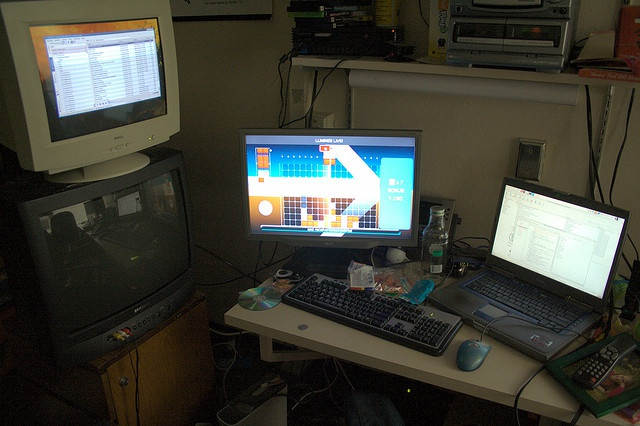Describe the objects in this image and their specific colors. I can see tv in black, gray, and darkgreen tones, tv in black, gray, lightblue, and darkgreen tones, tv in black, white, and cyan tones, laptop in black, beige, gray, and purple tones, and keyboard in black, gray, and purple tones in this image. 